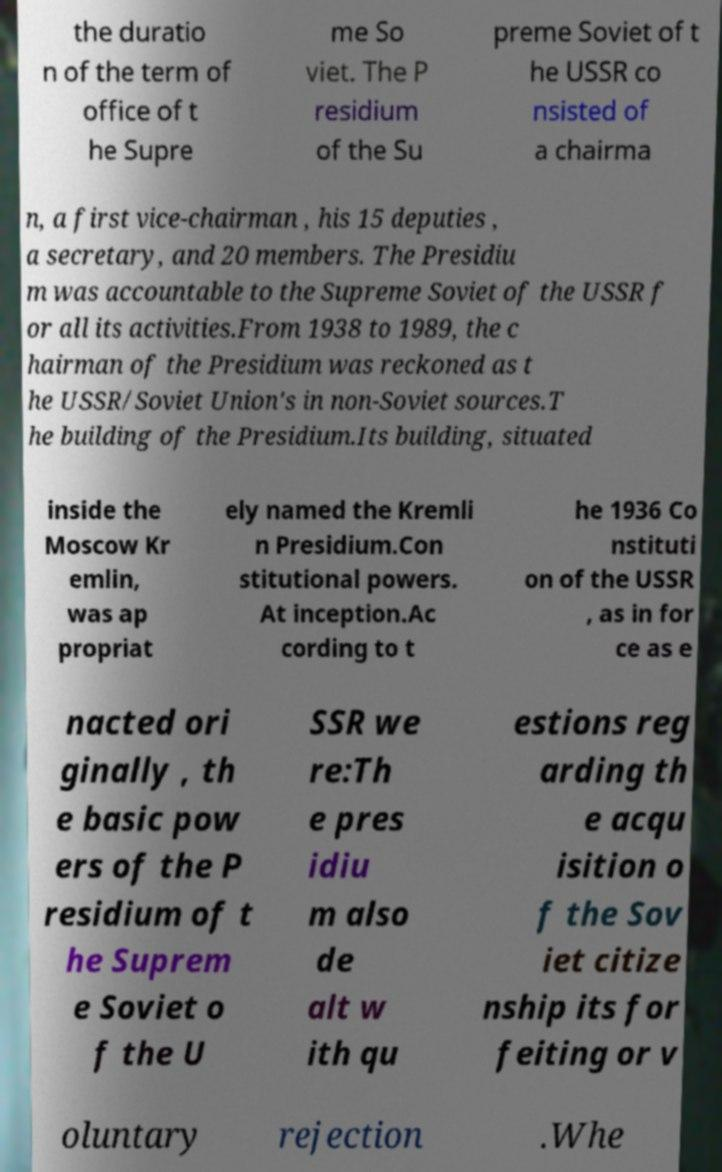I need the written content from this picture converted into text. Can you do that? the duratio n of the term of office of t he Supre me So viet. The P residium of the Su preme Soviet of t he USSR co nsisted of a chairma n, a first vice-chairman , his 15 deputies , a secretary, and 20 members. The Presidiu m was accountable to the Supreme Soviet of the USSR f or all its activities.From 1938 to 1989, the c hairman of the Presidium was reckoned as t he USSR/Soviet Union's in non-Soviet sources.T he building of the Presidium.Its building, situated inside the Moscow Kr emlin, was ap propriat ely named the Kremli n Presidium.Con stitutional powers. At inception.Ac cording to t he 1936 Co nstituti on of the USSR , as in for ce as e nacted ori ginally , th e basic pow ers of the P residium of t he Suprem e Soviet o f the U SSR we re:Th e pres idiu m also de alt w ith qu estions reg arding th e acqu isition o f the Sov iet citize nship its for feiting or v oluntary rejection .Whe 